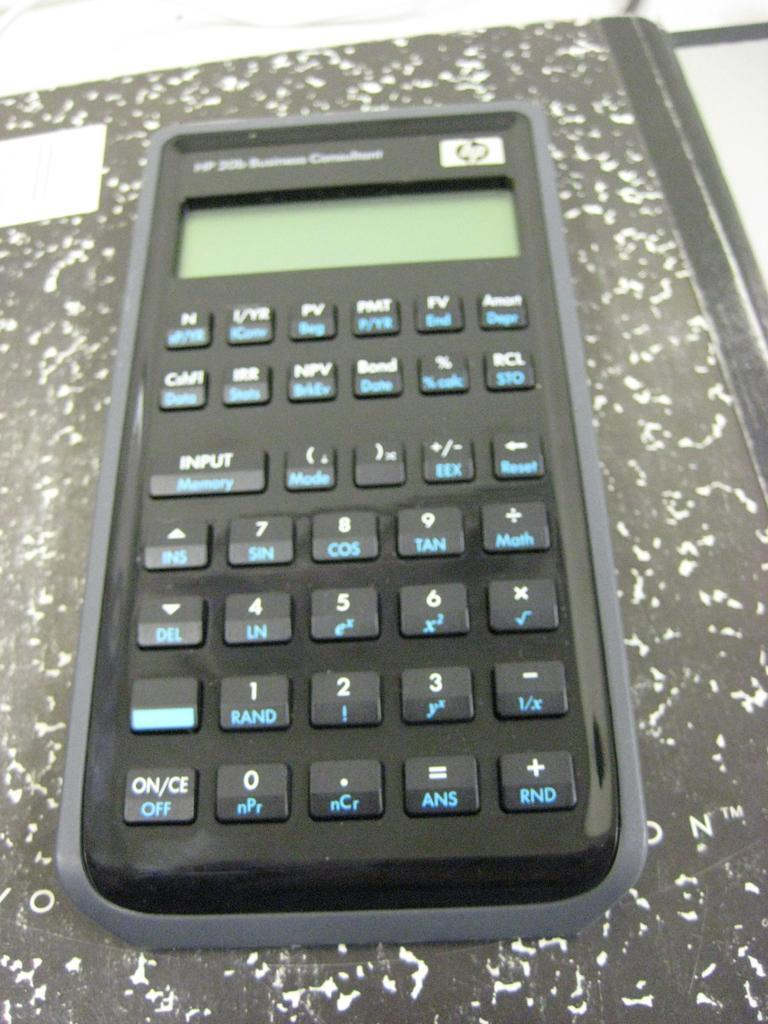<image>
Summarize the visual content of the image. An HP calculator has many extra buttons and scientific functions. 